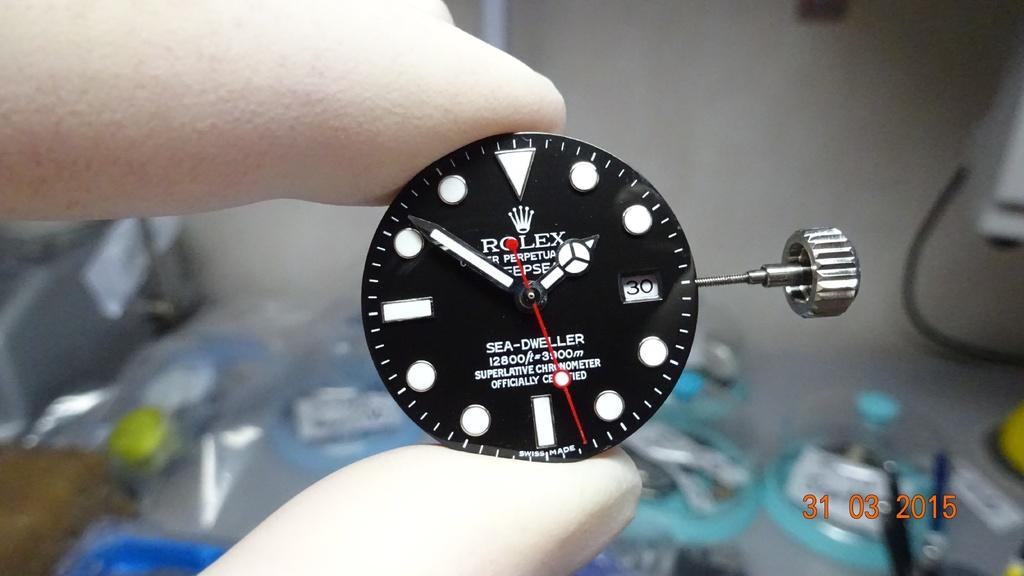<image>
Offer a succinct explanation of the picture presented. Person holding a wristwatch which says the word ROLEX on it. 